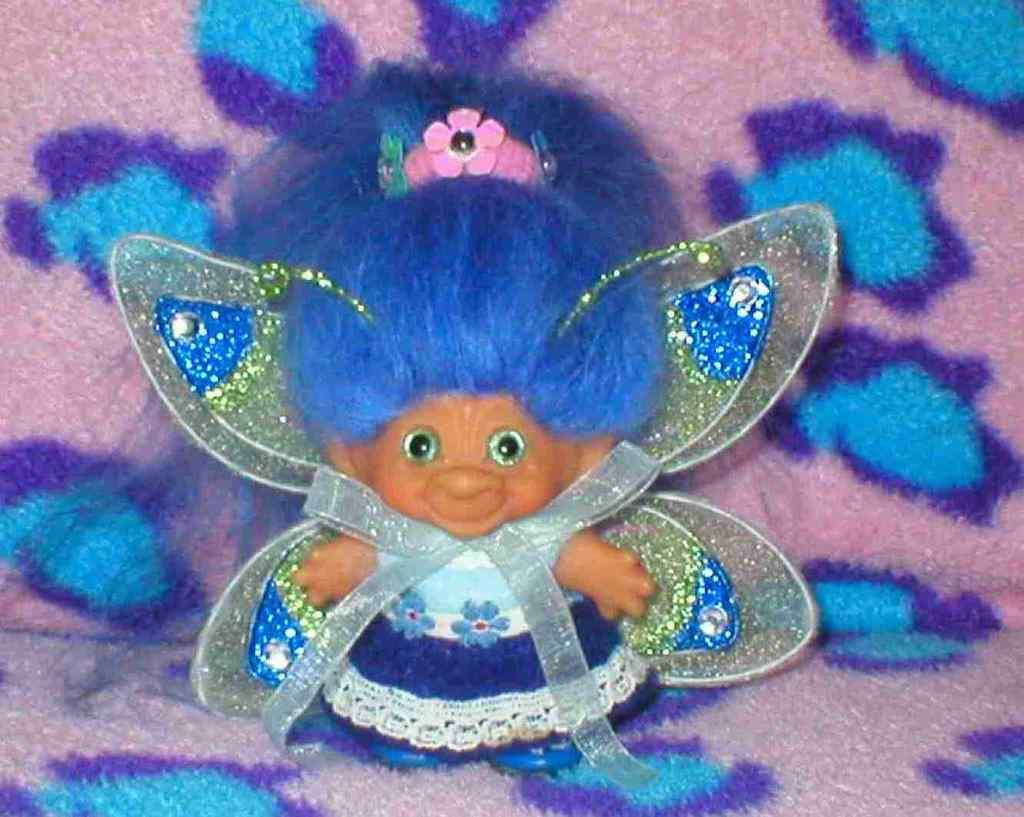What is the main subject in the center of the picture? There is a toy in the center of the picture. What color is the toy? The toy is blue in color. What feature does the toy have? The toy has wings. Where is the toy placed? The toy is placed on a bed sheet. What colors are present on the bed sheet? The bed sheet has pink and blue colors. What type of shoes can be seen on the toy in the image? There are no shoes present on the toy in the image; it is a toy with wings. 